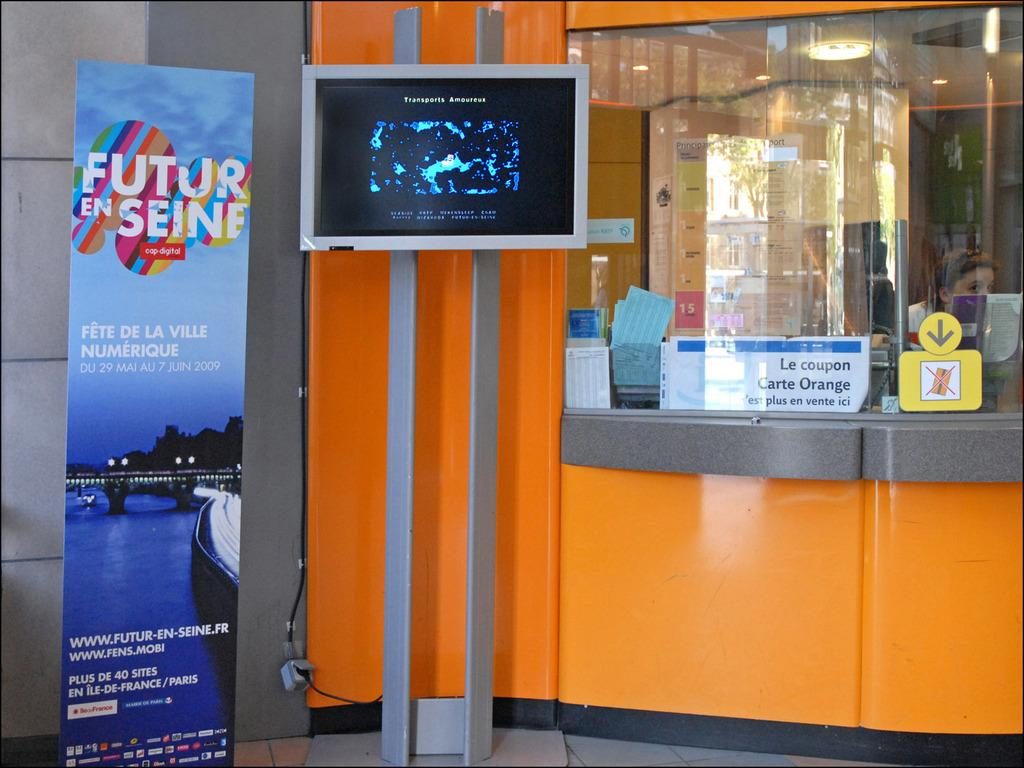<image>
Create a compact narrative representing the image presented. An orange booth has a sign next to it that says Future En Seine. 